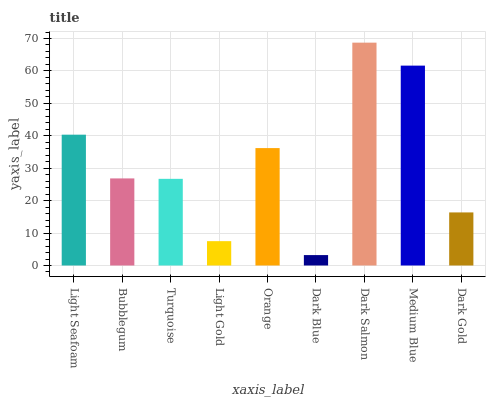Is Dark Blue the minimum?
Answer yes or no. Yes. Is Dark Salmon the maximum?
Answer yes or no. Yes. Is Bubblegum the minimum?
Answer yes or no. No. Is Bubblegum the maximum?
Answer yes or no. No. Is Light Seafoam greater than Bubblegum?
Answer yes or no. Yes. Is Bubblegum less than Light Seafoam?
Answer yes or no. Yes. Is Bubblegum greater than Light Seafoam?
Answer yes or no. No. Is Light Seafoam less than Bubblegum?
Answer yes or no. No. Is Bubblegum the high median?
Answer yes or no. Yes. Is Bubblegum the low median?
Answer yes or no. Yes. Is Light Gold the high median?
Answer yes or no. No. Is Medium Blue the low median?
Answer yes or no. No. 